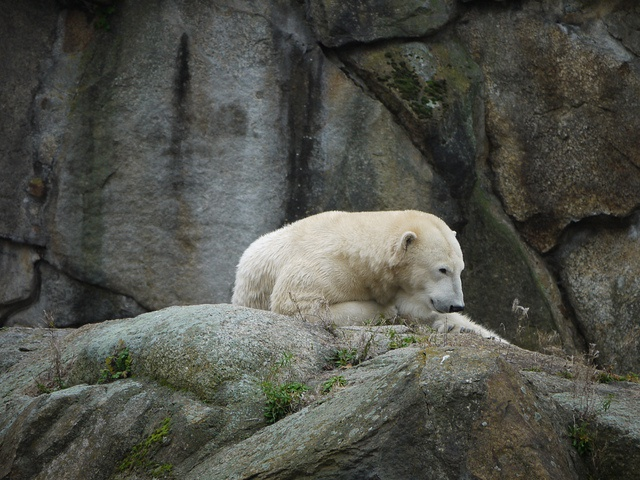Describe the objects in this image and their specific colors. I can see a bear in black, darkgray, lightgray, and gray tones in this image. 